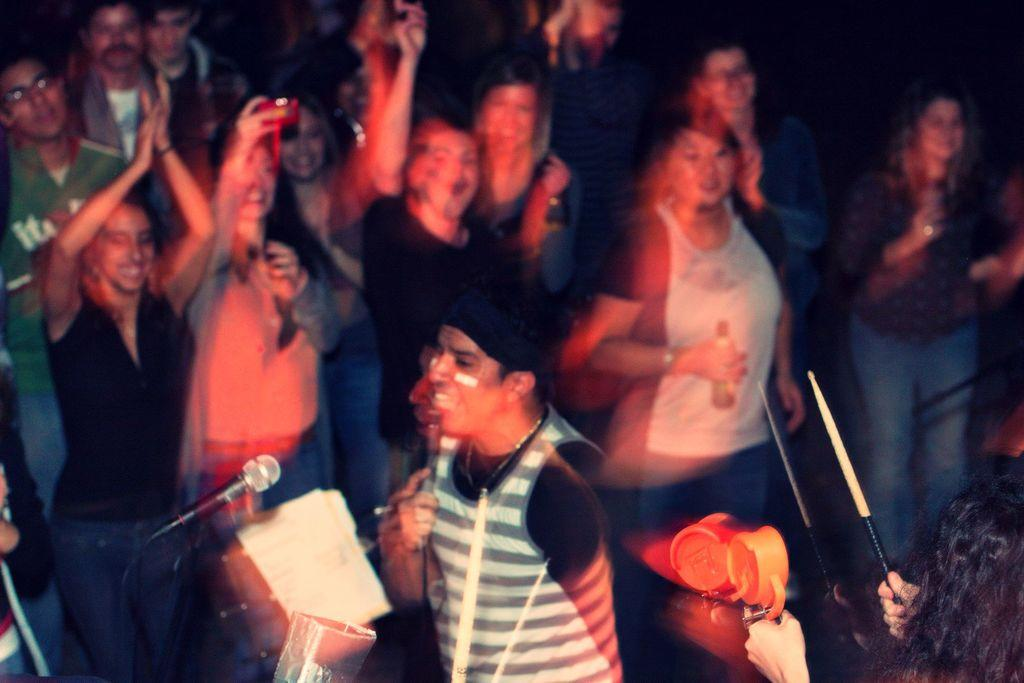How many people are in the image? There is a group of people standing in the image. What is one person holding in the image? One person is holding a stick and an object. What equipment is present for recording or amplifying sound? There is a mic with a stand in the image. Who is responsible for capturing the moment in the image? A person is holding a camera in the image. How many wings are visible on the lamp in the image? There is no lamp present in the image, and therefore no wings to count. 